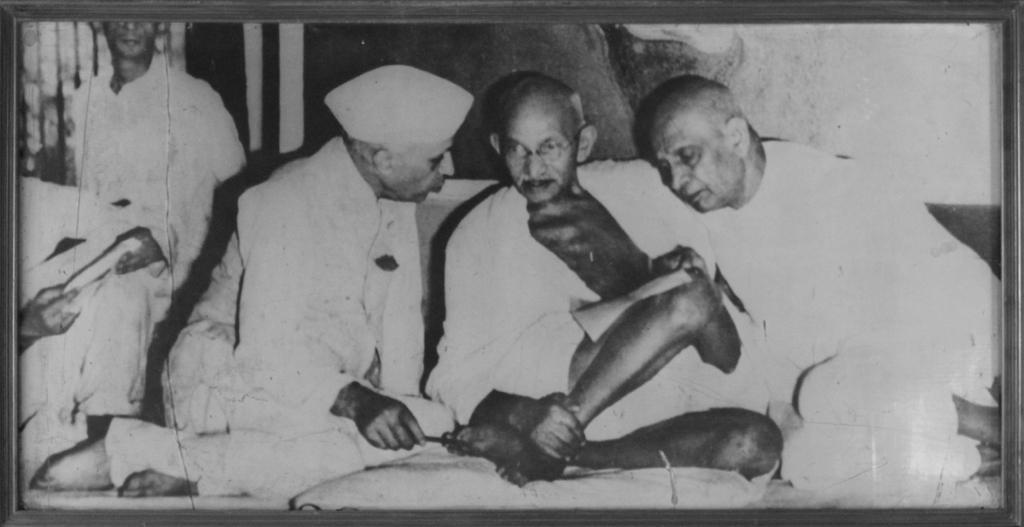Describe this image in one or two sentences. In this image I can see few people are sitting. I can also see this image is black and white in colour. 